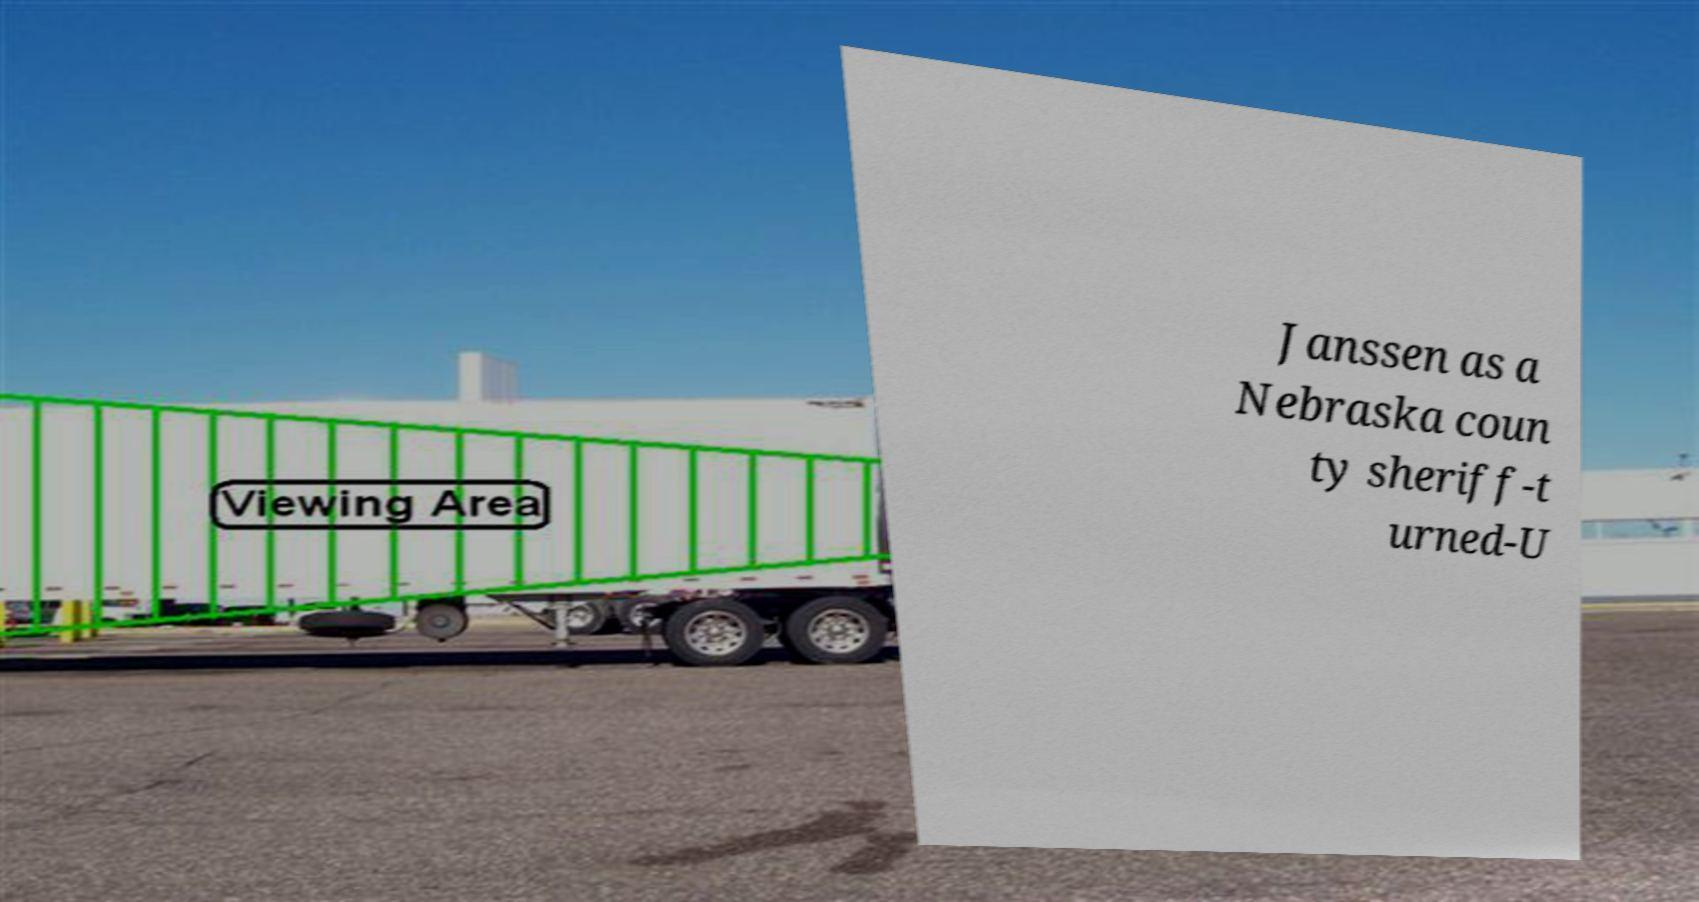There's text embedded in this image that I need extracted. Can you transcribe it verbatim? Janssen as a Nebraska coun ty sheriff-t urned-U 